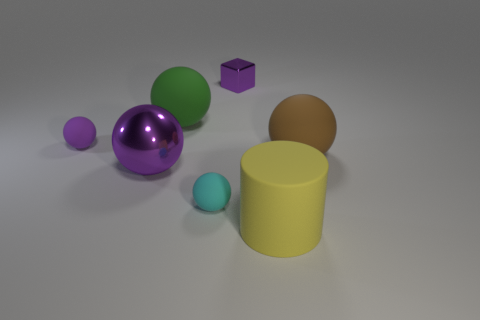Is there any other thing that is the same shape as the big yellow matte thing?
Your answer should be compact. No. What is the size of the thing that is to the left of the purple shiny thing that is in front of the block?
Provide a succinct answer. Small. Are there the same number of rubber balls left of the green object and cyan matte things that are in front of the large brown object?
Provide a succinct answer. Yes. The thing that is made of the same material as the tiny block is what color?
Your answer should be very brief. Purple. Does the yellow cylinder have the same material as the thing that is to the right of the large yellow matte object?
Your response must be concise. Yes. There is a big object that is both behind the yellow thing and to the right of the cube; what color is it?
Keep it short and to the point. Brown. What number of cylinders are tiny shiny things or blue matte things?
Your answer should be compact. 0. Does the green rubber object have the same shape as the purple metal thing that is in front of the green sphere?
Your response must be concise. Yes. What size is the purple object that is both behind the brown sphere and left of the tiny cyan matte thing?
Your answer should be compact. Small. What is the shape of the large metallic object?
Make the answer very short. Sphere. 